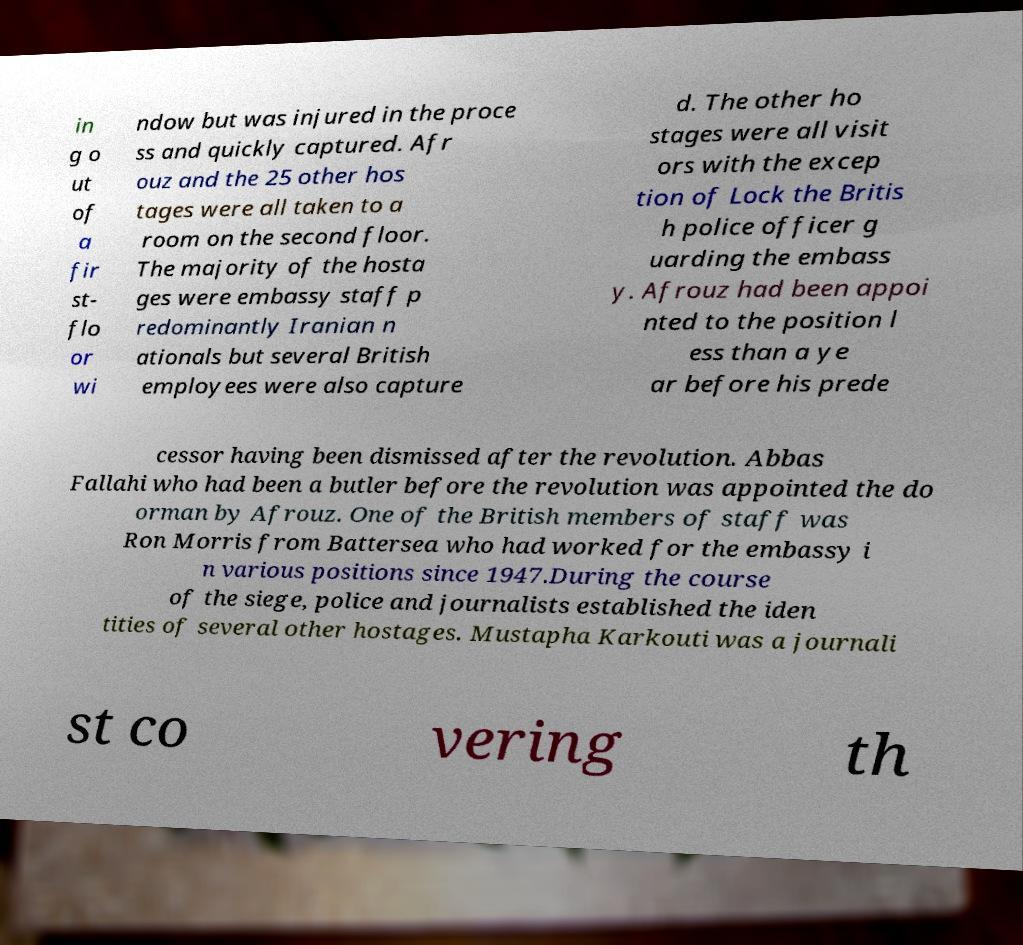What messages or text are displayed in this image? I need them in a readable, typed format. in g o ut of a fir st- flo or wi ndow but was injured in the proce ss and quickly captured. Afr ouz and the 25 other hos tages were all taken to a room on the second floor. The majority of the hosta ges were embassy staff p redominantly Iranian n ationals but several British employees were also capture d. The other ho stages were all visit ors with the excep tion of Lock the Britis h police officer g uarding the embass y. Afrouz had been appoi nted to the position l ess than a ye ar before his prede cessor having been dismissed after the revolution. Abbas Fallahi who had been a butler before the revolution was appointed the do orman by Afrouz. One of the British members of staff was Ron Morris from Battersea who had worked for the embassy i n various positions since 1947.During the course of the siege, police and journalists established the iden tities of several other hostages. Mustapha Karkouti was a journali st co vering th 